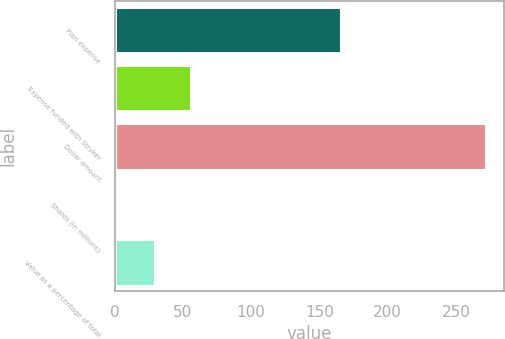Convert chart. <chart><loc_0><loc_0><loc_500><loc_500><bar_chart><fcel>Plan expense<fcel>Expense funded with Stryker<fcel>Dollar amount<fcel>Shares (in millions)<fcel>Value as a percentage of total<nl><fcel>166<fcel>56.24<fcel>272<fcel>2.3<fcel>29.27<nl></chart> 